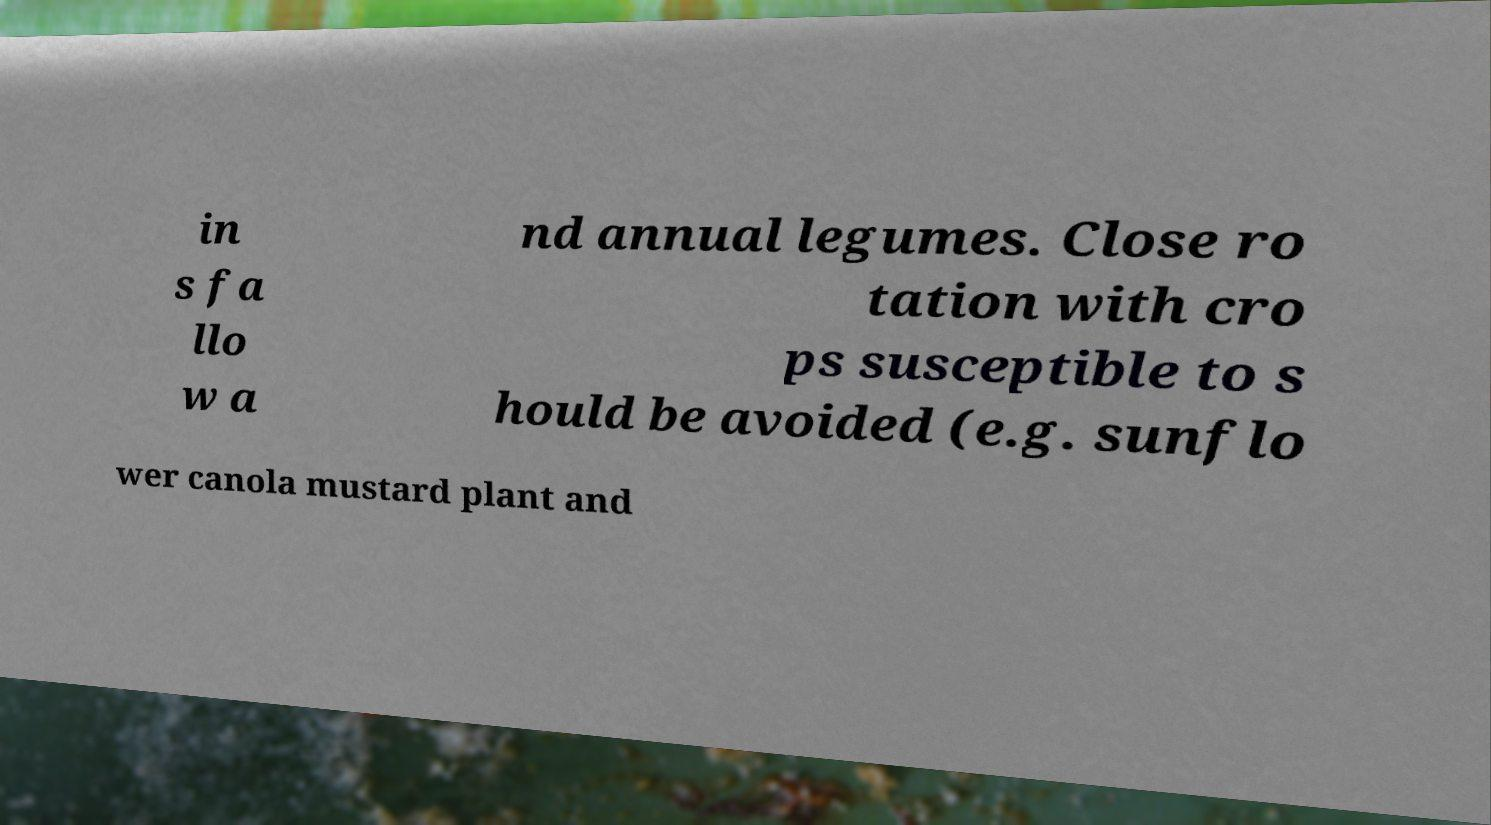What messages or text are displayed in this image? I need them in a readable, typed format. in s fa llo w a nd annual legumes. Close ro tation with cro ps susceptible to s hould be avoided (e.g. sunflo wer canola mustard plant and 